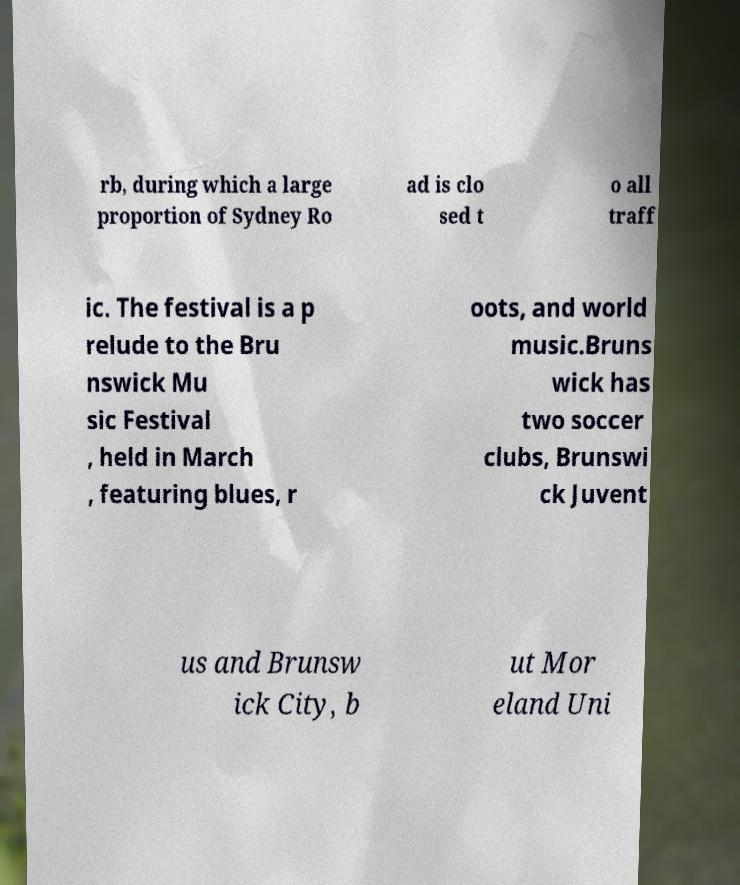What messages or text are displayed in this image? I need them in a readable, typed format. rb, during which a large proportion of Sydney Ro ad is clo sed t o all traff ic. The festival is a p relude to the Bru nswick Mu sic Festival , held in March , featuring blues, r oots, and world music.Bruns wick has two soccer clubs, Brunswi ck Juvent us and Brunsw ick City, b ut Mor eland Uni 